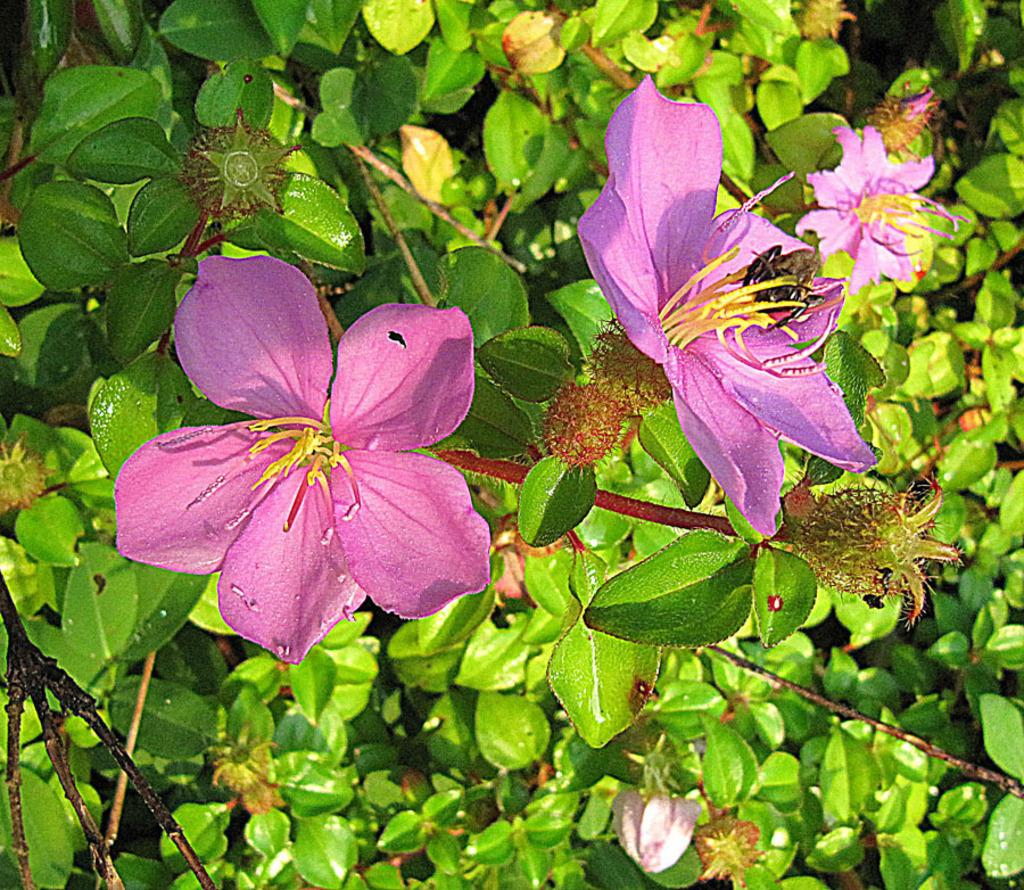What is present in the image? There is a plant in the image. What specific feature of the plant can be observed? The plant has flowers. Is there a trampoline visible in the image? No, there is no trampoline present in the image. The image only features a plant with flowers. 